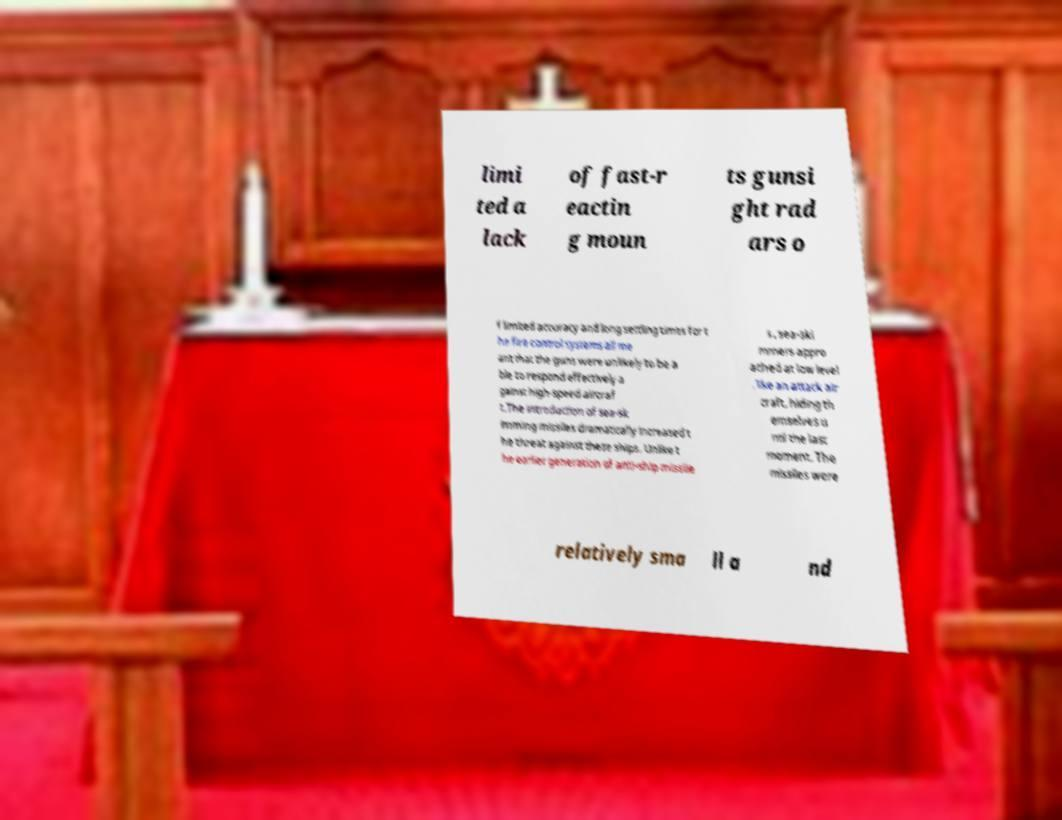Could you assist in decoding the text presented in this image and type it out clearly? limi ted a lack of fast-r eactin g moun ts gunsi ght rad ars o f limited accuracy and long settling times for t he fire control systems all me ant that the guns were unlikely to be a ble to respond effectively a gainst high-speed aircraf t.The introduction of sea-sk imming missiles dramatically increased t he threat against these ships. Unlike t he earlier generation of anti-ship missile s , sea-ski mmers appro ached at low level , like an attack air craft, hiding th emselves u ntil the last moment. The missiles were relatively sma ll a nd 